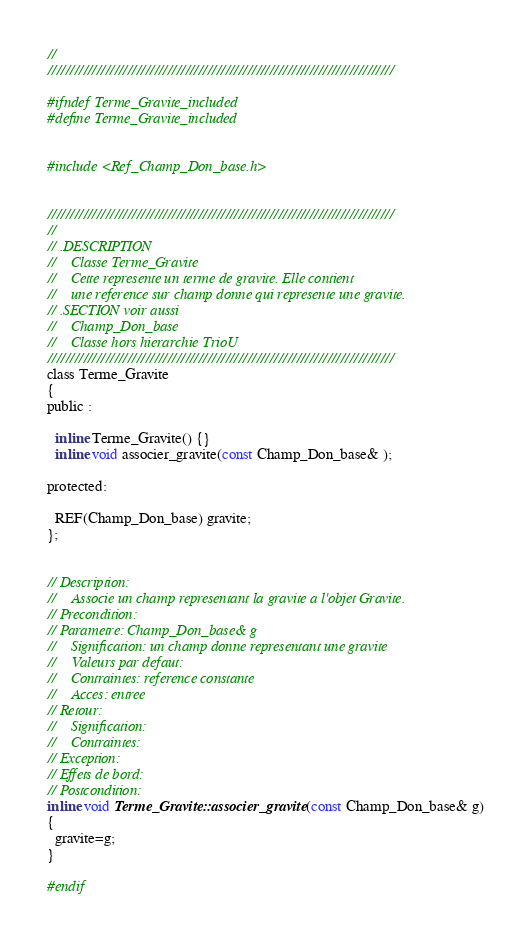<code> <loc_0><loc_0><loc_500><loc_500><_C_>//
//////////////////////////////////////////////////////////////////////////////

#ifndef Terme_Gravite_included
#define Terme_Gravite_included


#include <Ref_Champ_Don_base.h>


//////////////////////////////////////////////////////////////////////////////
//
// .DESCRIPTION
//    Classe Terme_Gravite
//    Cette represente un terme de gravite. Elle contient
//    une reference sur champ donne qui represente une gravite.
// .SECTION voir aussi
//    Champ_Don_base
//    Classe hors hierarchie TrioU
//////////////////////////////////////////////////////////////////////////////
class Terme_Gravite
{
public :

  inline Terme_Gravite() {}
  inline void associer_gravite(const Champ_Don_base& );

protected:

  REF(Champ_Don_base) gravite;
};


// Description:
//    Associe un champ representant la gravite a l'objet Gravite.
// Precondition:
// Parametre: Champ_Don_base& g
//    Signification: un champ donne representant une gravite
//    Valeurs par defaut:
//    Contraintes: reference constante
//    Acces: entree
// Retour:
//    Signification:
//    Contraintes:
// Exception:
// Effets de bord:
// Postcondition:
inline void Terme_Gravite::associer_gravite(const Champ_Don_base& g)
{
  gravite=g;
}

#endif
</code> 